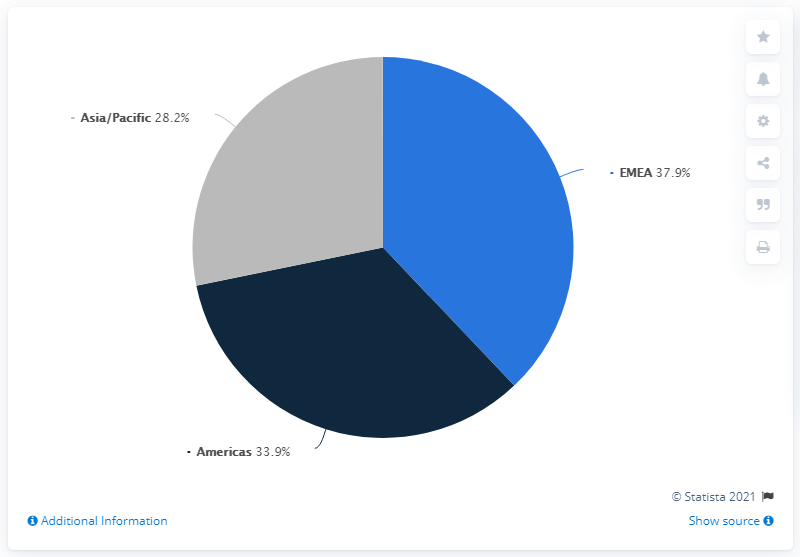Identify some key points in this picture. In 2020, Puma's Americas region accounted for 37.9% of the company's total sales. The difference in percentage share between the region with the highest Puma share and the region with the lowest Puma share is 9.7%. According to a recent survey, Puma's market share in America is 33.9%. 